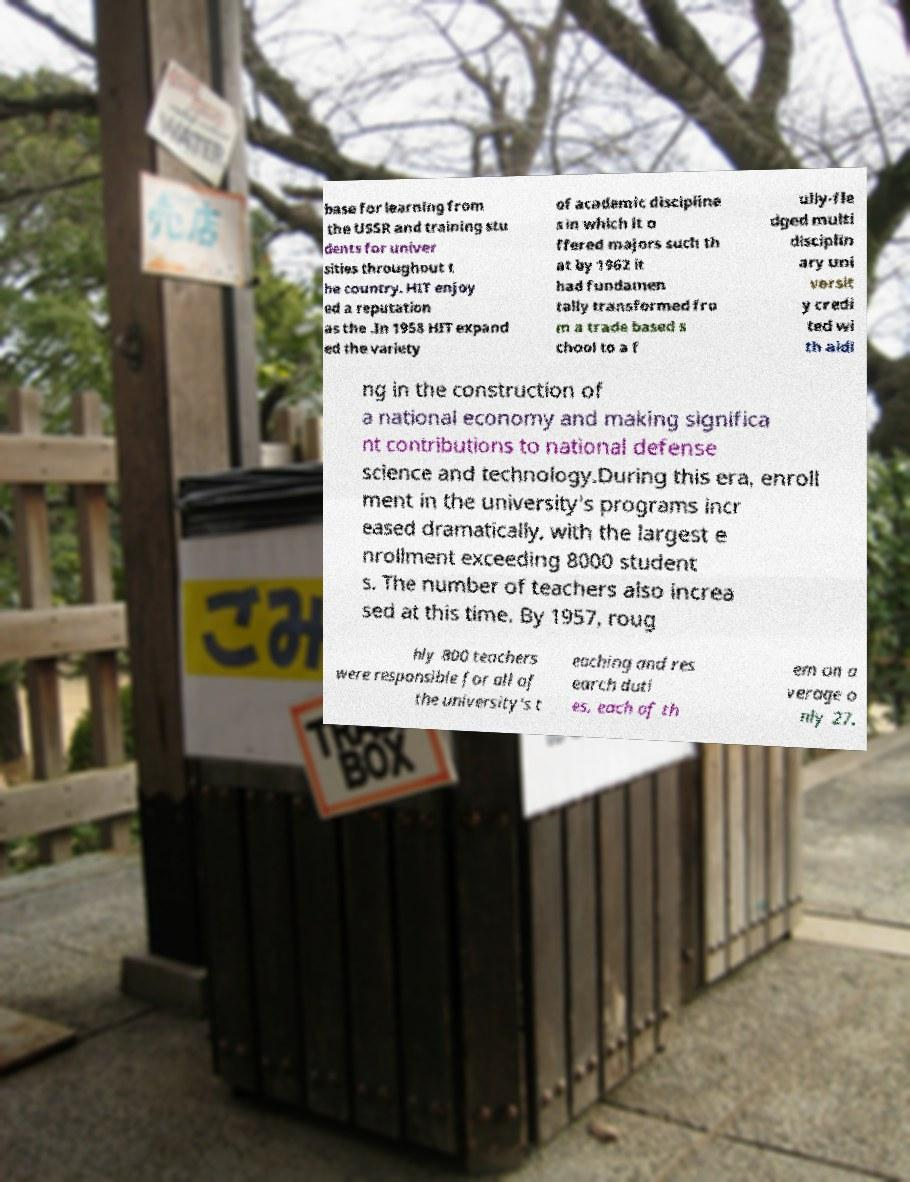Please identify and transcribe the text found in this image. base for learning from the USSR and training stu dents for univer sities throughout t he country. HIT enjoy ed a reputation as the .In 1958 HIT expand ed the variety of academic discipline s in which it o ffered majors such th at by 1962 it had fundamen tally transformed fro m a trade based s chool to a f ully-fle dged multi disciplin ary uni versit y credi ted wi th aidi ng in the construction of a national economy and making significa nt contributions to national defense science and technology.During this era, enroll ment in the university's programs incr eased dramatically, with the largest e nrollment exceeding 8000 student s. The number of teachers also increa sed at this time. By 1957, roug hly 800 teachers were responsible for all of the university's t eaching and res earch duti es, each of th em on a verage o nly 27. 